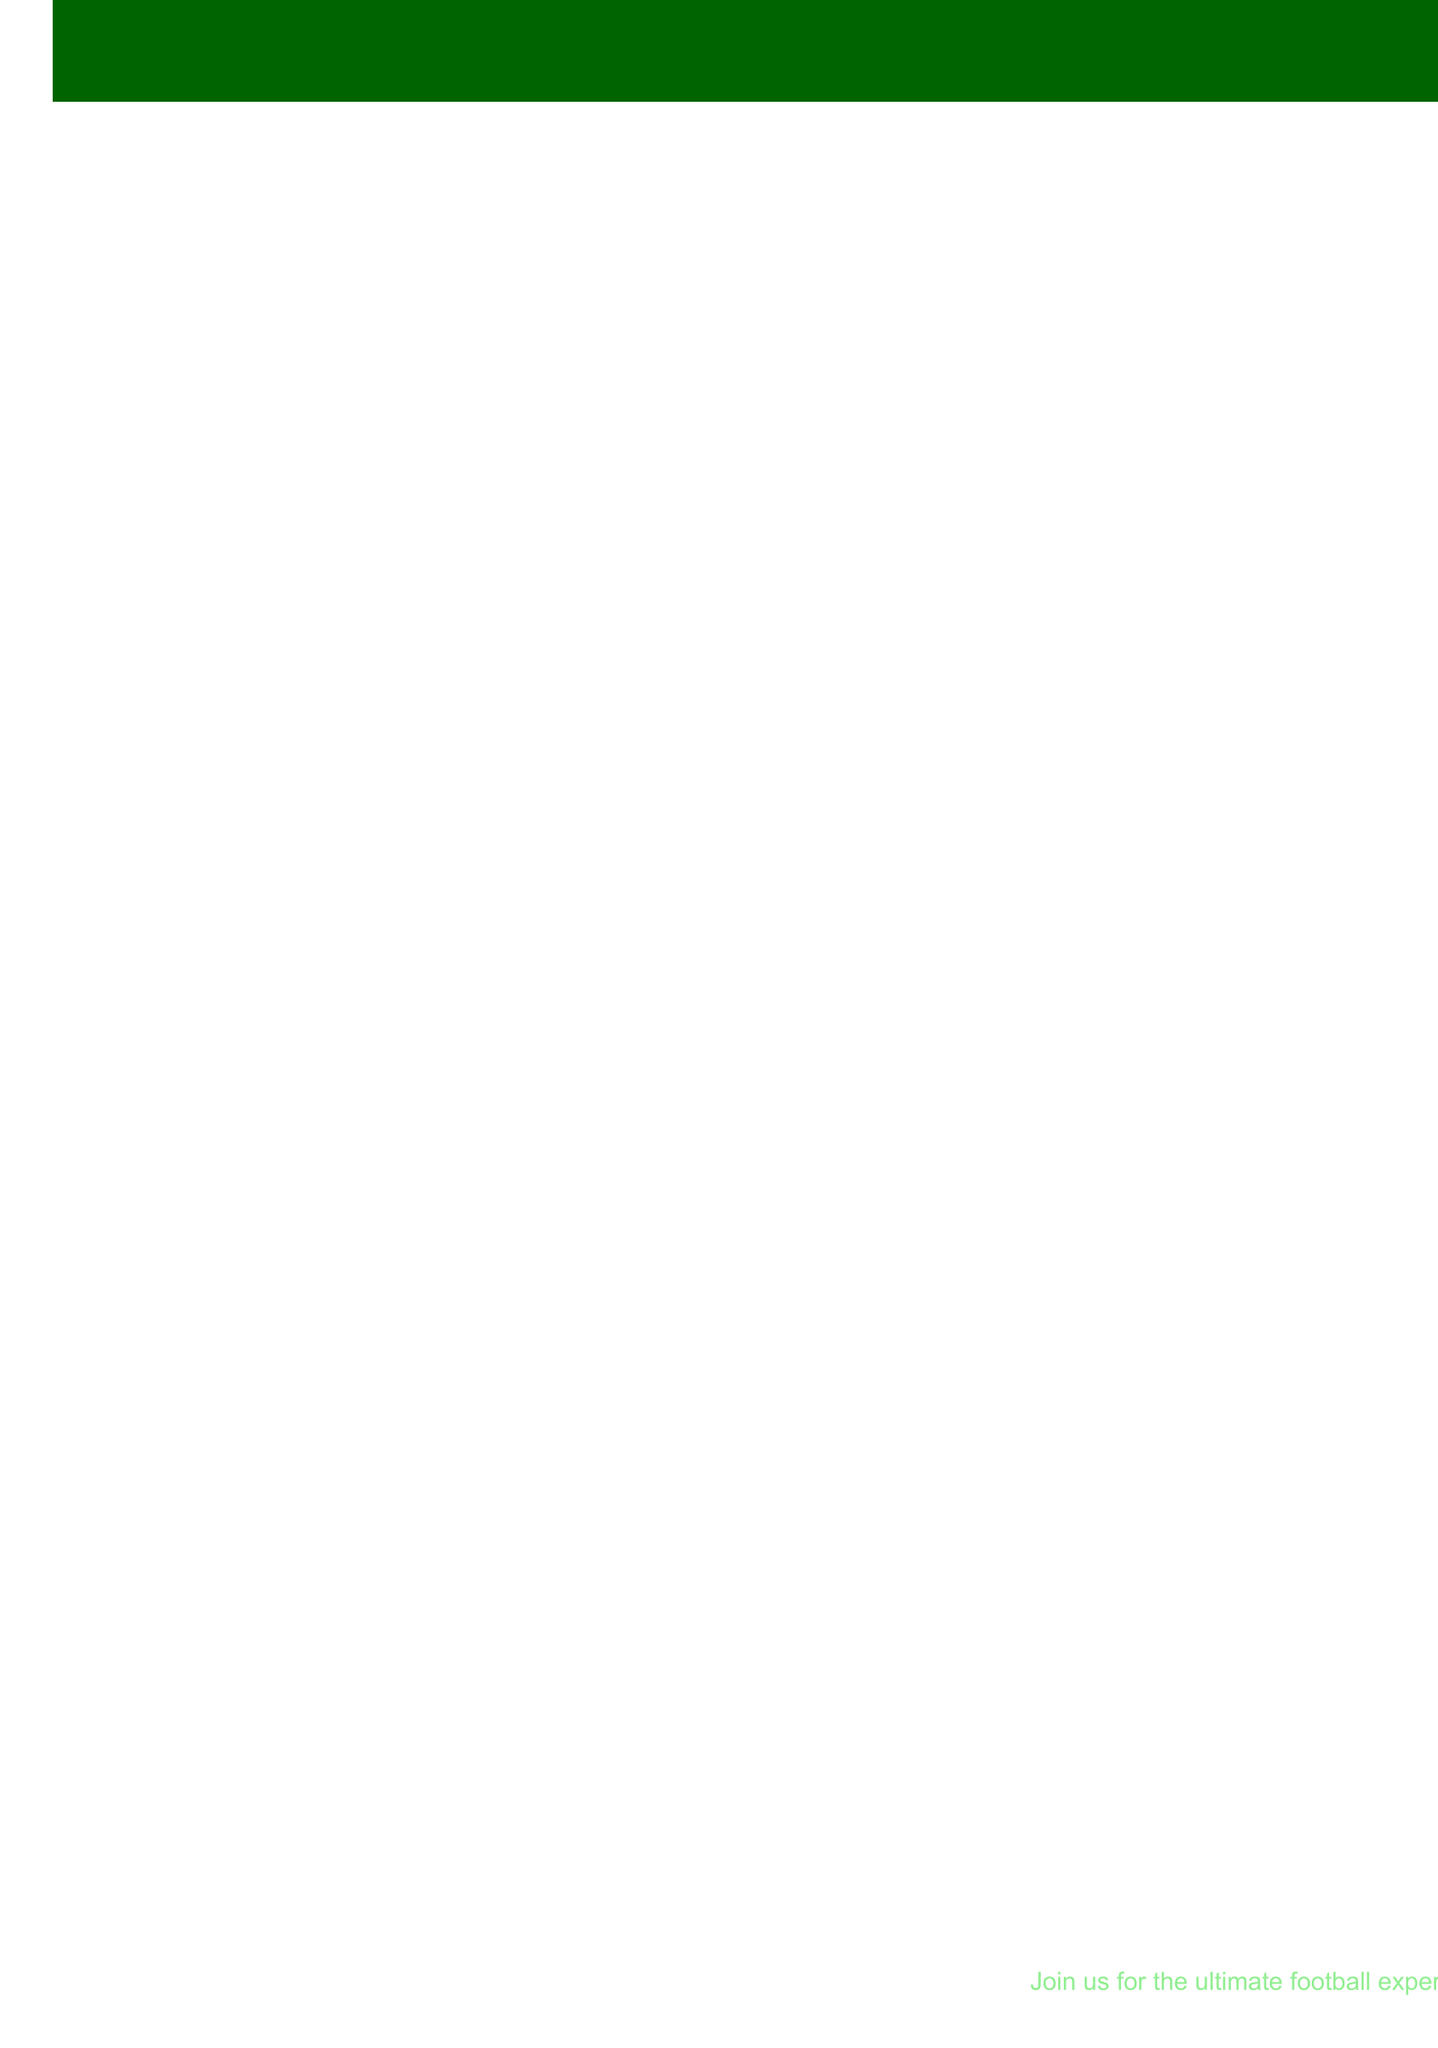What is the event name? The event name is stated at the top of the document as the title.
Answer: FIFA World Cup 2026 Viewing Party When is the final match scheduled? The date for the final match is mentioned in the key dates section of the document.
Answer: July 19, 2026 What is the capacity of Real Sports Bar & Grill? The capacity is listed in the venue details for Real Sports Bar & Grill.
Answer: 350 Which venue is hosting the opening match viewing party? The viewing party location for the opening match is specified in the match schedule.
Answer: The Football Factory at Legends What special event occurs on June 1, 2026? This date is mentioned in the special events section of the document.
Answer: Pre-tournament Predictions Contest How often does the Half-time Trivia Challenge occur? The frequency of this challenge is clearly mentioned in the special events section.
Answer: Every match Which country is not a host for the FIFA World Cup 2026? The host countries are listed in a separate section, highlighting the countries involved.
Answer: None (all listed are hosts) What merchandise is available for fans? The merchandise section lists different items that fans can purchase.
Answer: Official FIFA World Cup 2026 jerseys and scarves What social media handle is used for Instagram? The Instagram handle is specified in the social media section of the document.
Answer: @fifawc2026viewingparty What activities can fans participate in during the viewing parties? The fan activities section outlines various participatory events available.
Answer: Face painting with national team colors 